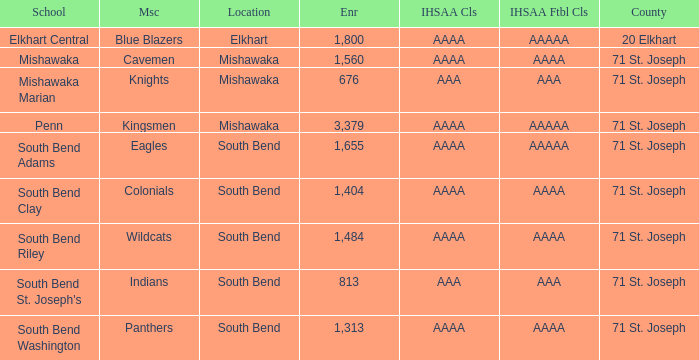Could you help me parse every detail presented in this table? {'header': ['School', 'Msc', 'Location', 'Enr', 'IHSAA Cls', 'IHSAA Ftbl Cls', 'County'], 'rows': [['Elkhart Central', 'Blue Blazers', 'Elkhart', '1,800', 'AAAA', 'AAAAA', '20 Elkhart'], ['Mishawaka', 'Cavemen', 'Mishawaka', '1,560', 'AAAA', 'AAAA', '71 St. Joseph'], ['Mishawaka Marian', 'Knights', 'Mishawaka', '676', 'AAA', 'AAA', '71 St. Joseph'], ['Penn', 'Kingsmen', 'Mishawaka', '3,379', 'AAAA', 'AAAAA', '71 St. Joseph'], ['South Bend Adams', 'Eagles', 'South Bend', '1,655', 'AAAA', 'AAAAA', '71 St. Joseph'], ['South Bend Clay', 'Colonials', 'South Bend', '1,404', 'AAAA', 'AAAA', '71 St. Joseph'], ['South Bend Riley', 'Wildcats', 'South Bend', '1,484', 'AAAA', 'AAAA', '71 St. Joseph'], ["South Bend St. Joseph's", 'Indians', 'South Bend', '813', 'AAA', 'AAA', '71 St. Joseph'], ['South Bend Washington', 'Panthers', 'South Bend', '1,313', 'AAAA', 'AAAA', '71 St. Joseph']]} What school has south bend as the location, with indians as the mascot? South Bend St. Joseph's. 